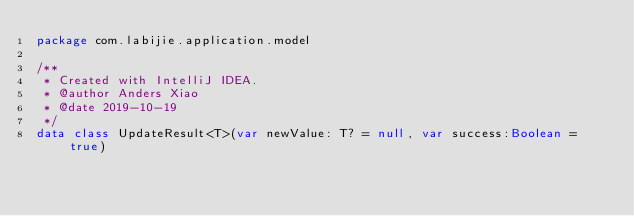<code> <loc_0><loc_0><loc_500><loc_500><_Kotlin_>package com.labijie.application.model

/**
 * Created with IntelliJ IDEA.
 * @author Anders Xiao
 * @date 2019-10-19
 */
data class UpdateResult<T>(var newValue: T? = null, var success:Boolean = true)</code> 